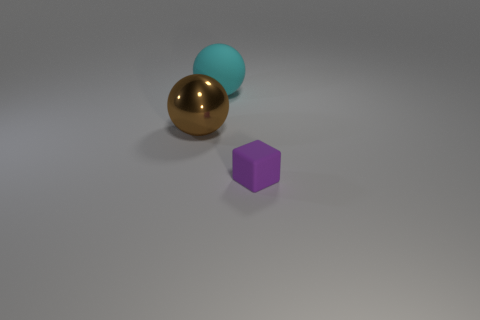Add 2 big cyan matte spheres. How many objects exist? 5 Subtract all spheres. How many objects are left? 1 Add 1 tiny red shiny spheres. How many tiny red shiny spheres exist? 1 Subtract 0 blue blocks. How many objects are left? 3 Subtract all blue cubes. Subtract all blue balls. How many cubes are left? 1 Subtract all small purple matte cubes. Subtract all cyan metallic cubes. How many objects are left? 2 Add 1 purple matte cubes. How many purple matte cubes are left? 2 